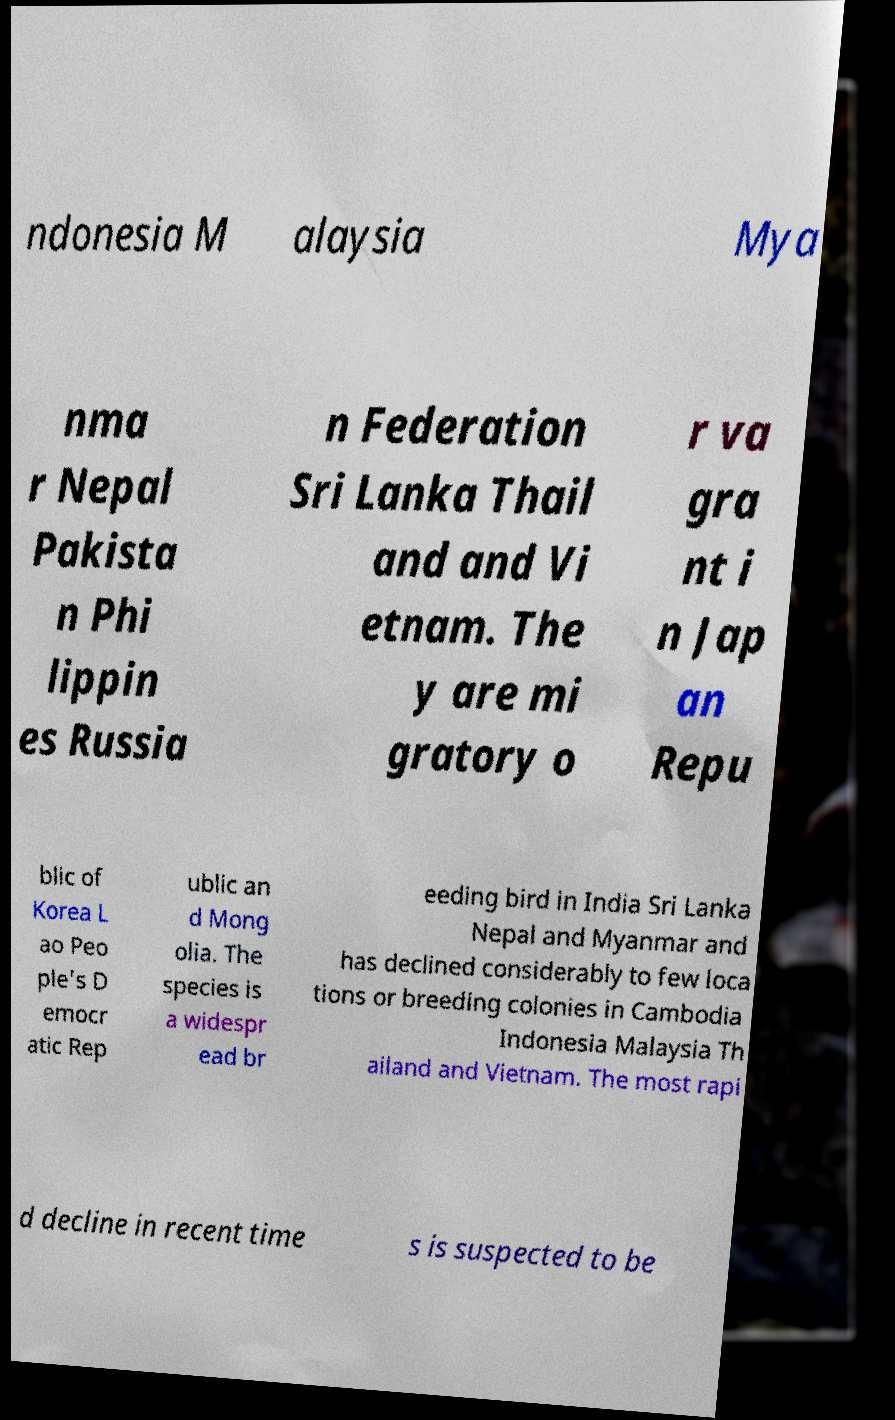I need the written content from this picture converted into text. Can you do that? ndonesia M alaysia Mya nma r Nepal Pakista n Phi lippin es Russia n Federation Sri Lanka Thail and and Vi etnam. The y are mi gratory o r va gra nt i n Jap an Repu blic of Korea L ao Peo ple's D emocr atic Rep ublic an d Mong olia. The species is a widespr ead br eeding bird in India Sri Lanka Nepal and Myanmar and has declined considerably to few loca tions or breeding colonies in Cambodia Indonesia Malaysia Th ailand and Vietnam. The most rapi d decline in recent time s is suspected to be 